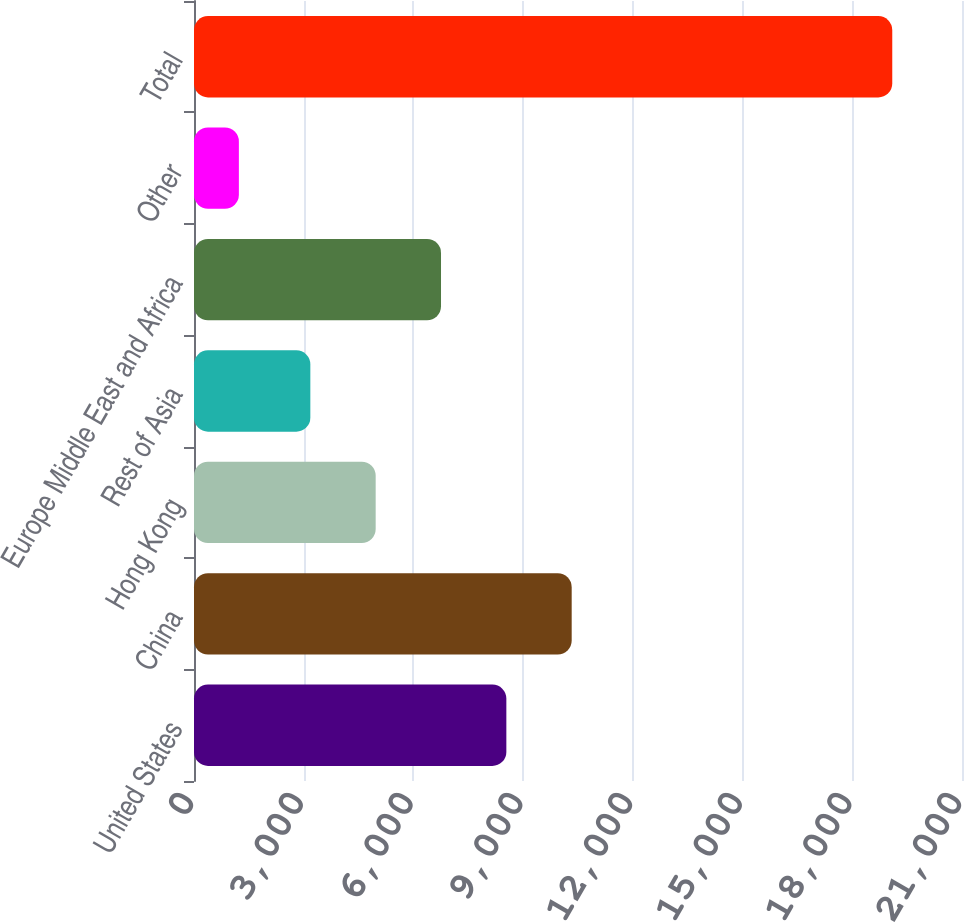<chart> <loc_0><loc_0><loc_500><loc_500><bar_chart><fcel>United States<fcel>China<fcel>Hong Kong<fcel>Rest of Asia<fcel>Europe Middle East and Africa<fcel>Other<fcel>Total<nl><fcel>8540.8<fcel>10327.4<fcel>4967.6<fcel>3181<fcel>6754.2<fcel>1227<fcel>19093<nl></chart> 